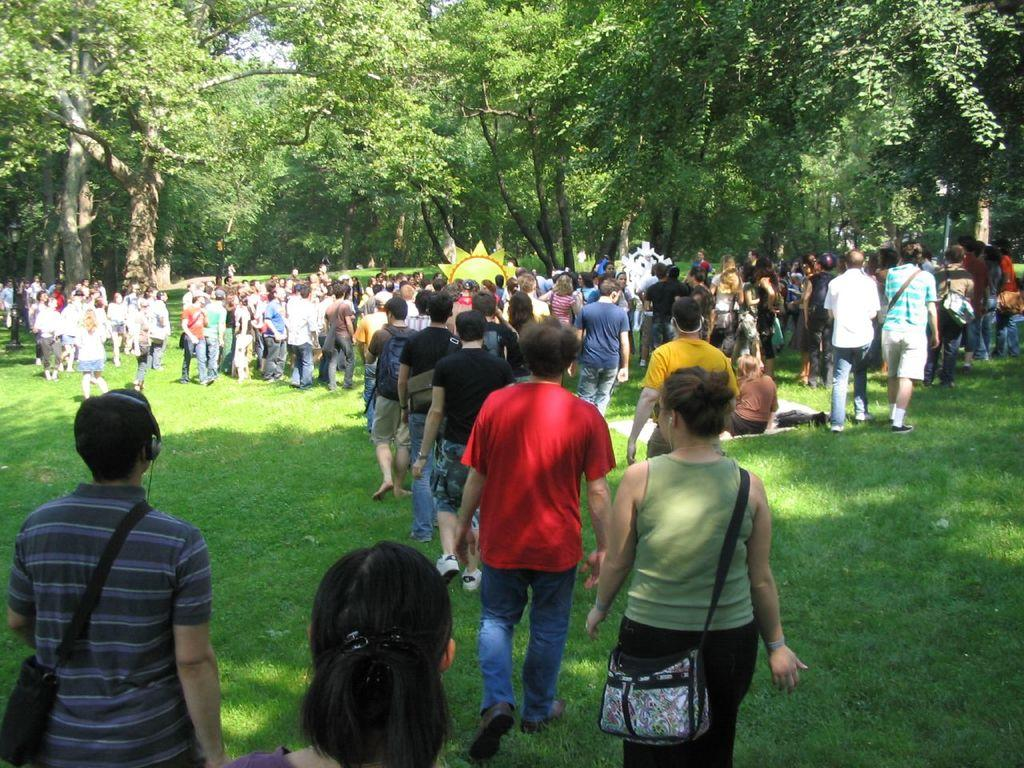How many people are present in the image? There are many people in the image. What are some people wearing in the image? Some people are wearing bags in the image. What type of surface is underfoot in the image? There is grass on the ground in the image. What can be seen in the distance in the image? There are trees in the background of the image. What does the mom say to the people in the image? There is no mention of a mom or any dialogue in the image, so it is not possible to answer that question. 